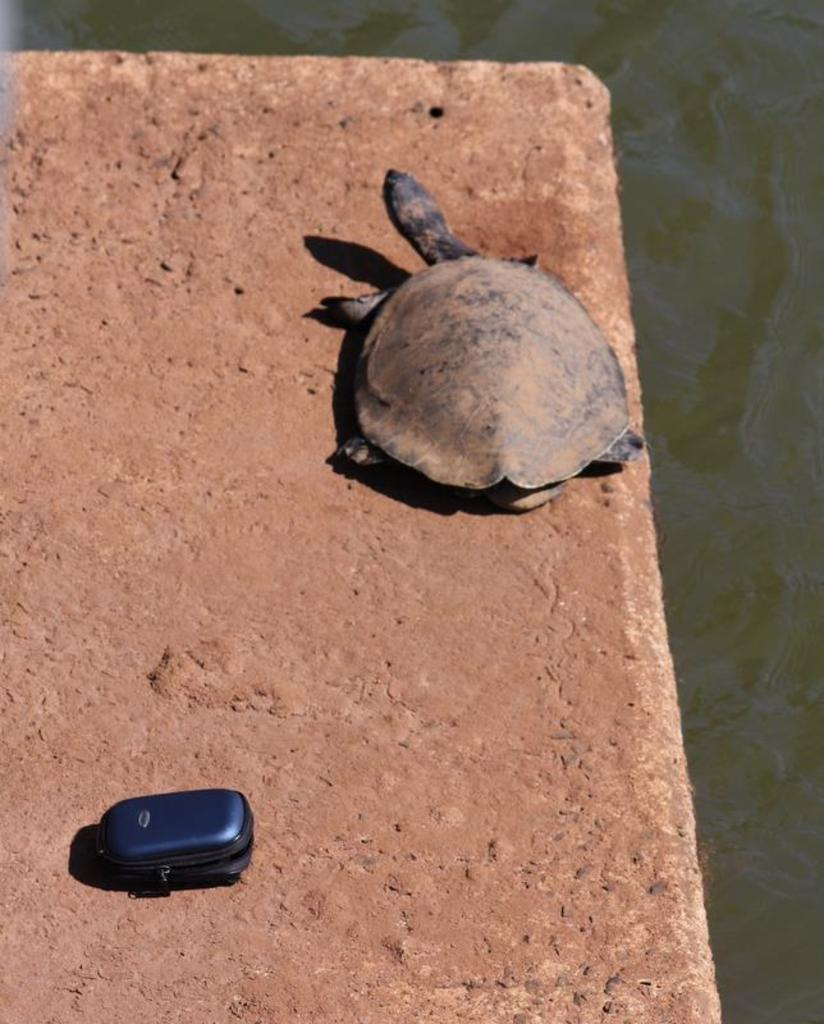What type of animal is present in the image? There is a turtle in the image. What is the surface on which the turtle is situated? There is a mud surface in the image. Can you describe the unspecified object in the image? Unfortunately, the facts provided do not give any details about the unspecified object. What else is visible in the image besides the turtle and the mud surface? There is water visible in the image. What type of drink is the turtle holding in the image? The turtle is not holding any drink in the image; it is a turtle on a mud surface with water visible. What direction is the sun facing in the image? The facts provided do not mention the sun or its direction in the image. 